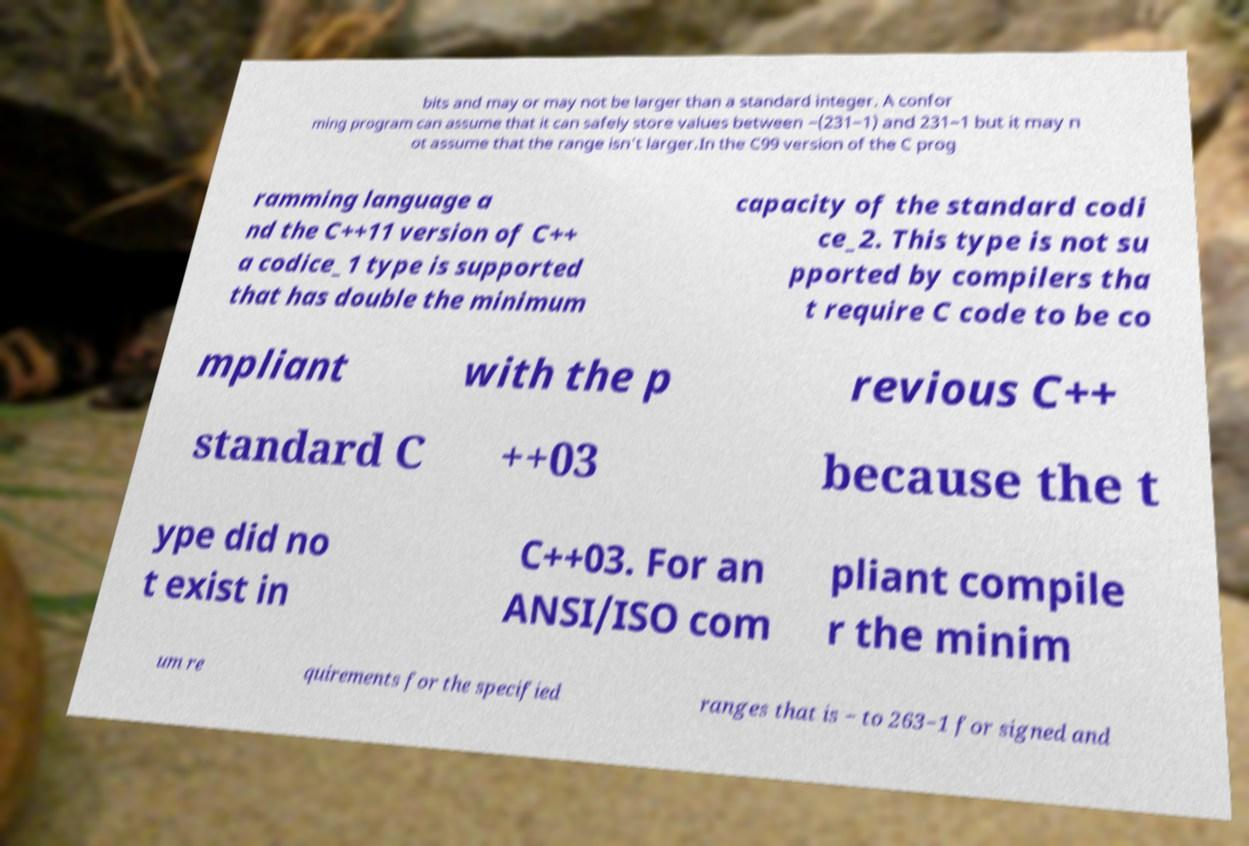Please read and relay the text visible in this image. What does it say? bits and may or may not be larger than a standard integer. A confor ming program can assume that it can safely store values between −(231−1) and 231−1 but it may n ot assume that the range isn't larger.In the C99 version of the C prog ramming language a nd the C++11 version of C++ a codice_1 type is supported that has double the minimum capacity of the standard codi ce_2. This type is not su pported by compilers tha t require C code to be co mpliant with the p revious C++ standard C ++03 because the t ype did no t exist in C++03. For an ANSI/ISO com pliant compile r the minim um re quirements for the specified ranges that is − to 263−1 for signed and 